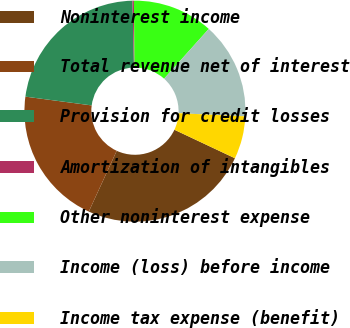<chart> <loc_0><loc_0><loc_500><loc_500><pie_chart><fcel>Noninterest income<fcel>Total revenue net of interest<fcel>Provision for credit losses<fcel>Amortization of intangibles<fcel>Other noninterest expense<fcel>Income (loss) before income<fcel>Income tax expense (benefit)<nl><fcel>24.85%<fcel>20.24%<fcel>22.54%<fcel>0.21%<fcel>11.79%<fcel>14.1%<fcel>6.26%<nl></chart> 